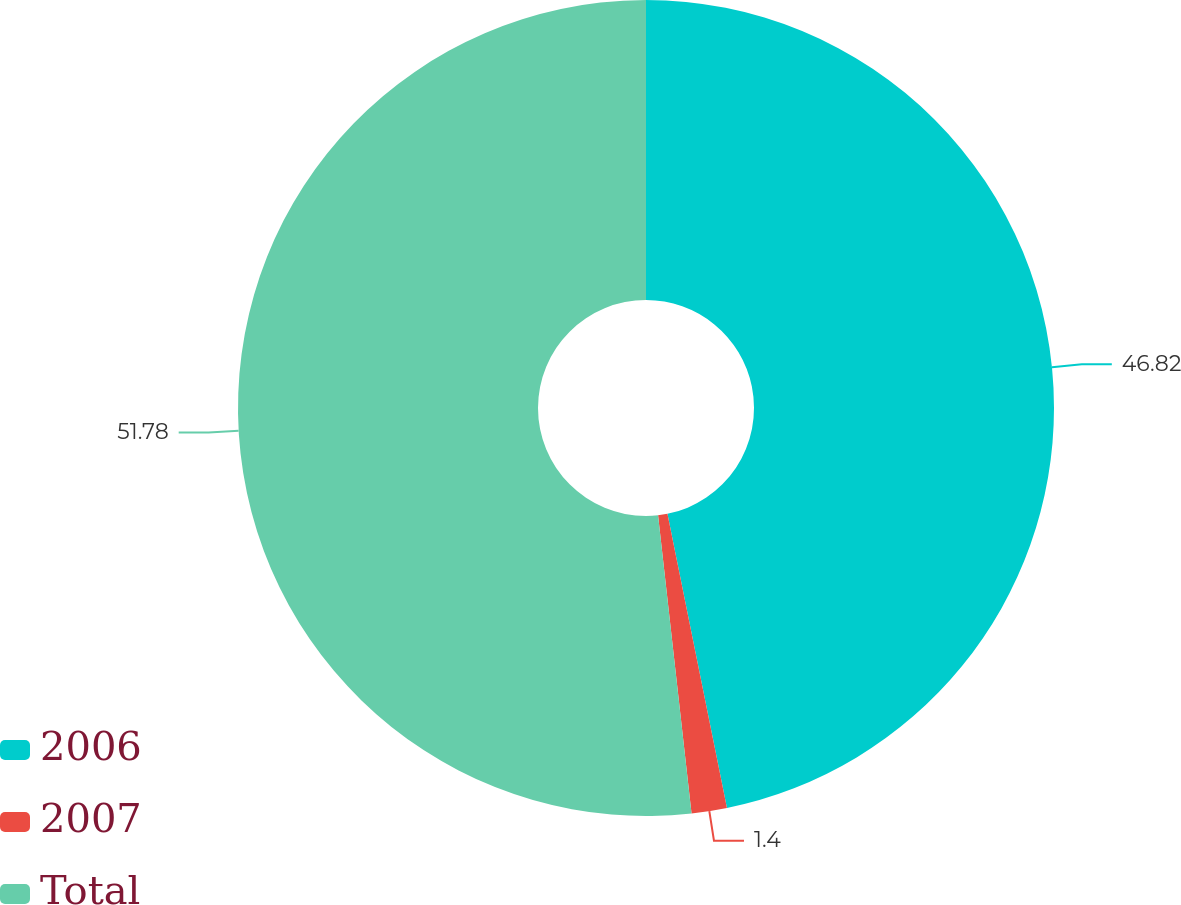Convert chart to OTSL. <chart><loc_0><loc_0><loc_500><loc_500><pie_chart><fcel>2006<fcel>2007<fcel>Total<nl><fcel>46.82%<fcel>1.4%<fcel>51.78%<nl></chart> 